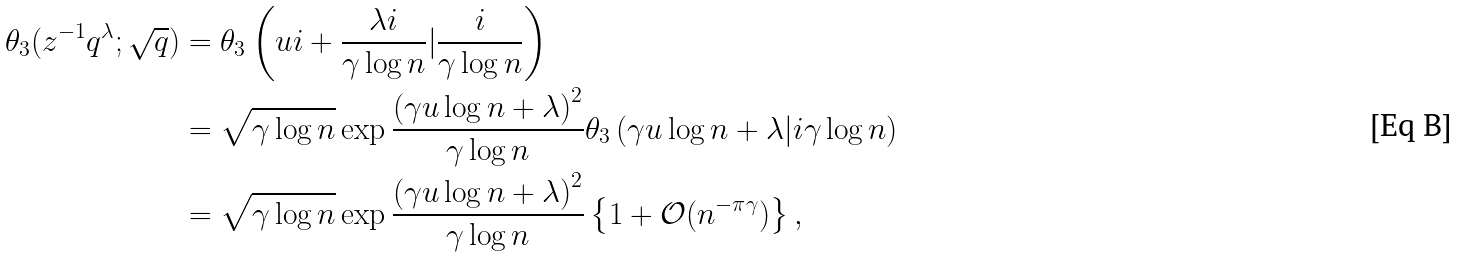<formula> <loc_0><loc_0><loc_500><loc_500>\theta _ { 3 } ( z ^ { - 1 } q ^ { \lambda } ; \sqrt { q } ) & = \theta _ { 3 } \left ( u i + \frac { \lambda i } { \gamma \log n } | \frac { i } { \gamma \log n } \right ) \\ & = \sqrt { \gamma \log n } \exp \frac { \left ( \gamma u \log n + \lambda \right ) ^ { 2 } } { \gamma \log n } \theta _ { 3 } \left ( \gamma u \log n + \lambda | i \gamma \log n \right ) \\ & = \sqrt { \gamma \log n } \exp \frac { \left ( \gamma u \log n + \lambda \right ) ^ { 2 } } { \gamma \log n } \left \{ 1 + \mathcal { O } ( n ^ { - \pi \gamma } ) \right \} ,</formula> 